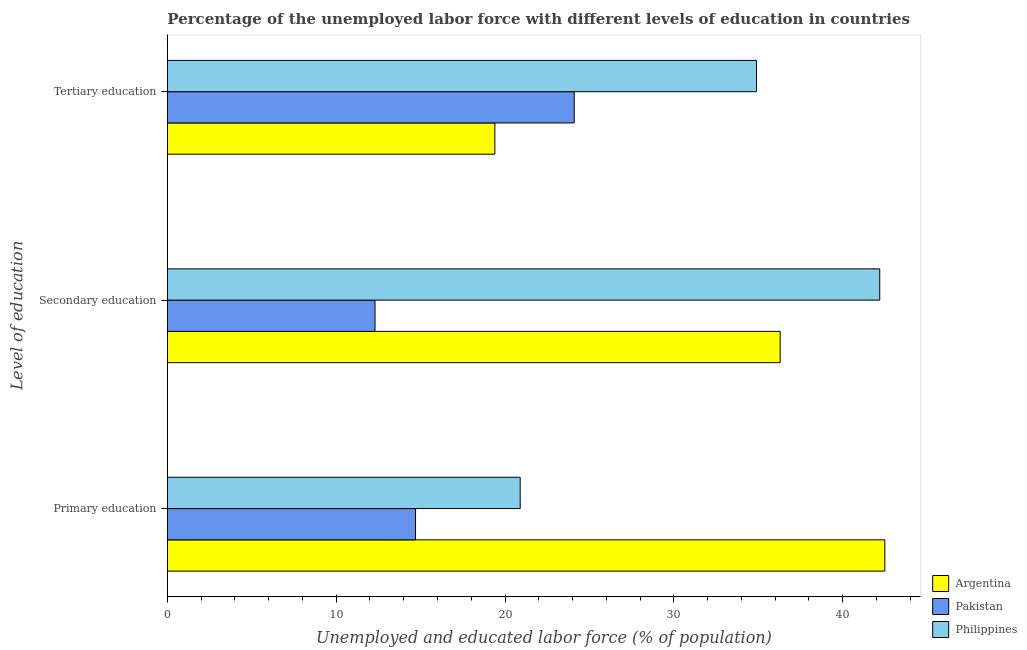Are the number of bars per tick equal to the number of legend labels?
Make the answer very short. Yes. How many bars are there on the 3rd tick from the top?
Offer a very short reply. 3. What is the label of the 3rd group of bars from the top?
Your answer should be compact. Primary education. What is the percentage of labor force who received secondary education in Argentina?
Give a very brief answer. 36.3. Across all countries, what is the maximum percentage of labor force who received primary education?
Offer a terse response. 42.5. Across all countries, what is the minimum percentage of labor force who received secondary education?
Offer a very short reply. 12.3. In which country was the percentage of labor force who received tertiary education maximum?
Provide a succinct answer. Philippines. What is the total percentage of labor force who received secondary education in the graph?
Make the answer very short. 90.8. What is the difference between the percentage of labor force who received secondary education in Philippines and that in Pakistan?
Your response must be concise. 29.9. What is the difference between the percentage of labor force who received primary education in Argentina and the percentage of labor force who received tertiary education in Pakistan?
Make the answer very short. 18.4. What is the average percentage of labor force who received tertiary education per country?
Your answer should be very brief. 26.13. What is the difference between the percentage of labor force who received tertiary education and percentage of labor force who received secondary education in Pakistan?
Your answer should be very brief. 11.8. In how many countries, is the percentage of labor force who received secondary education greater than 14 %?
Offer a very short reply. 2. What is the ratio of the percentage of labor force who received tertiary education in Philippines to that in Argentina?
Ensure brevity in your answer.  1.8. What is the difference between the highest and the second highest percentage of labor force who received secondary education?
Provide a succinct answer. 5.9. What is the difference between the highest and the lowest percentage of labor force who received primary education?
Your response must be concise. 27.8. Is the sum of the percentage of labor force who received tertiary education in Argentina and Philippines greater than the maximum percentage of labor force who received secondary education across all countries?
Keep it short and to the point. Yes. How many bars are there?
Provide a succinct answer. 9. Are all the bars in the graph horizontal?
Offer a terse response. Yes. How many countries are there in the graph?
Ensure brevity in your answer.  3. What is the difference between two consecutive major ticks on the X-axis?
Keep it short and to the point. 10. Does the graph contain any zero values?
Provide a short and direct response. No. Where does the legend appear in the graph?
Your answer should be very brief. Bottom right. How many legend labels are there?
Your answer should be compact. 3. How are the legend labels stacked?
Provide a succinct answer. Vertical. What is the title of the graph?
Keep it short and to the point. Percentage of the unemployed labor force with different levels of education in countries. What is the label or title of the X-axis?
Ensure brevity in your answer.  Unemployed and educated labor force (% of population). What is the label or title of the Y-axis?
Ensure brevity in your answer.  Level of education. What is the Unemployed and educated labor force (% of population) in Argentina in Primary education?
Provide a succinct answer. 42.5. What is the Unemployed and educated labor force (% of population) in Pakistan in Primary education?
Ensure brevity in your answer.  14.7. What is the Unemployed and educated labor force (% of population) of Philippines in Primary education?
Make the answer very short. 20.9. What is the Unemployed and educated labor force (% of population) in Argentina in Secondary education?
Offer a very short reply. 36.3. What is the Unemployed and educated labor force (% of population) in Pakistan in Secondary education?
Your response must be concise. 12.3. What is the Unemployed and educated labor force (% of population) of Philippines in Secondary education?
Ensure brevity in your answer.  42.2. What is the Unemployed and educated labor force (% of population) of Argentina in Tertiary education?
Offer a very short reply. 19.4. What is the Unemployed and educated labor force (% of population) of Pakistan in Tertiary education?
Keep it short and to the point. 24.1. What is the Unemployed and educated labor force (% of population) in Philippines in Tertiary education?
Your answer should be compact. 34.9. Across all Level of education, what is the maximum Unemployed and educated labor force (% of population) in Argentina?
Offer a terse response. 42.5. Across all Level of education, what is the maximum Unemployed and educated labor force (% of population) in Pakistan?
Give a very brief answer. 24.1. Across all Level of education, what is the maximum Unemployed and educated labor force (% of population) in Philippines?
Your answer should be compact. 42.2. Across all Level of education, what is the minimum Unemployed and educated labor force (% of population) in Argentina?
Offer a terse response. 19.4. Across all Level of education, what is the minimum Unemployed and educated labor force (% of population) in Pakistan?
Make the answer very short. 12.3. Across all Level of education, what is the minimum Unemployed and educated labor force (% of population) of Philippines?
Your answer should be compact. 20.9. What is the total Unemployed and educated labor force (% of population) in Argentina in the graph?
Offer a very short reply. 98.2. What is the total Unemployed and educated labor force (% of population) in Pakistan in the graph?
Your answer should be very brief. 51.1. What is the difference between the Unemployed and educated labor force (% of population) in Pakistan in Primary education and that in Secondary education?
Keep it short and to the point. 2.4. What is the difference between the Unemployed and educated labor force (% of population) of Philippines in Primary education and that in Secondary education?
Offer a terse response. -21.3. What is the difference between the Unemployed and educated labor force (% of population) of Argentina in Primary education and that in Tertiary education?
Provide a short and direct response. 23.1. What is the difference between the Unemployed and educated labor force (% of population) in Argentina in Secondary education and that in Tertiary education?
Offer a very short reply. 16.9. What is the difference between the Unemployed and educated labor force (% of population) of Philippines in Secondary education and that in Tertiary education?
Ensure brevity in your answer.  7.3. What is the difference between the Unemployed and educated labor force (% of population) in Argentina in Primary education and the Unemployed and educated labor force (% of population) in Pakistan in Secondary education?
Offer a terse response. 30.2. What is the difference between the Unemployed and educated labor force (% of population) of Argentina in Primary education and the Unemployed and educated labor force (% of population) of Philippines in Secondary education?
Make the answer very short. 0.3. What is the difference between the Unemployed and educated labor force (% of population) of Pakistan in Primary education and the Unemployed and educated labor force (% of population) of Philippines in Secondary education?
Keep it short and to the point. -27.5. What is the difference between the Unemployed and educated labor force (% of population) of Argentina in Primary education and the Unemployed and educated labor force (% of population) of Pakistan in Tertiary education?
Ensure brevity in your answer.  18.4. What is the difference between the Unemployed and educated labor force (% of population) of Argentina in Primary education and the Unemployed and educated labor force (% of population) of Philippines in Tertiary education?
Provide a succinct answer. 7.6. What is the difference between the Unemployed and educated labor force (% of population) of Pakistan in Primary education and the Unemployed and educated labor force (% of population) of Philippines in Tertiary education?
Provide a short and direct response. -20.2. What is the difference between the Unemployed and educated labor force (% of population) in Argentina in Secondary education and the Unemployed and educated labor force (% of population) in Pakistan in Tertiary education?
Give a very brief answer. 12.2. What is the difference between the Unemployed and educated labor force (% of population) of Argentina in Secondary education and the Unemployed and educated labor force (% of population) of Philippines in Tertiary education?
Keep it short and to the point. 1.4. What is the difference between the Unemployed and educated labor force (% of population) of Pakistan in Secondary education and the Unemployed and educated labor force (% of population) of Philippines in Tertiary education?
Ensure brevity in your answer.  -22.6. What is the average Unemployed and educated labor force (% of population) of Argentina per Level of education?
Give a very brief answer. 32.73. What is the average Unemployed and educated labor force (% of population) of Pakistan per Level of education?
Offer a very short reply. 17.03. What is the average Unemployed and educated labor force (% of population) of Philippines per Level of education?
Give a very brief answer. 32.67. What is the difference between the Unemployed and educated labor force (% of population) of Argentina and Unemployed and educated labor force (% of population) of Pakistan in Primary education?
Ensure brevity in your answer.  27.8. What is the difference between the Unemployed and educated labor force (% of population) of Argentina and Unemployed and educated labor force (% of population) of Philippines in Primary education?
Provide a succinct answer. 21.6. What is the difference between the Unemployed and educated labor force (% of population) in Argentina and Unemployed and educated labor force (% of population) in Pakistan in Secondary education?
Offer a terse response. 24. What is the difference between the Unemployed and educated labor force (% of population) of Pakistan and Unemployed and educated labor force (% of population) of Philippines in Secondary education?
Provide a short and direct response. -29.9. What is the difference between the Unemployed and educated labor force (% of population) in Argentina and Unemployed and educated labor force (% of population) in Pakistan in Tertiary education?
Your response must be concise. -4.7. What is the difference between the Unemployed and educated labor force (% of population) in Argentina and Unemployed and educated labor force (% of population) in Philippines in Tertiary education?
Give a very brief answer. -15.5. What is the difference between the Unemployed and educated labor force (% of population) in Pakistan and Unemployed and educated labor force (% of population) in Philippines in Tertiary education?
Make the answer very short. -10.8. What is the ratio of the Unemployed and educated labor force (% of population) in Argentina in Primary education to that in Secondary education?
Your answer should be very brief. 1.17. What is the ratio of the Unemployed and educated labor force (% of population) in Pakistan in Primary education to that in Secondary education?
Provide a succinct answer. 1.2. What is the ratio of the Unemployed and educated labor force (% of population) of Philippines in Primary education to that in Secondary education?
Keep it short and to the point. 0.5. What is the ratio of the Unemployed and educated labor force (% of population) in Argentina in Primary education to that in Tertiary education?
Provide a short and direct response. 2.19. What is the ratio of the Unemployed and educated labor force (% of population) of Pakistan in Primary education to that in Tertiary education?
Provide a short and direct response. 0.61. What is the ratio of the Unemployed and educated labor force (% of population) of Philippines in Primary education to that in Tertiary education?
Provide a short and direct response. 0.6. What is the ratio of the Unemployed and educated labor force (% of population) in Argentina in Secondary education to that in Tertiary education?
Offer a terse response. 1.87. What is the ratio of the Unemployed and educated labor force (% of population) of Pakistan in Secondary education to that in Tertiary education?
Make the answer very short. 0.51. What is the ratio of the Unemployed and educated labor force (% of population) in Philippines in Secondary education to that in Tertiary education?
Your response must be concise. 1.21. What is the difference between the highest and the second highest Unemployed and educated labor force (% of population) in Pakistan?
Your response must be concise. 9.4. What is the difference between the highest and the second highest Unemployed and educated labor force (% of population) of Philippines?
Your response must be concise. 7.3. What is the difference between the highest and the lowest Unemployed and educated labor force (% of population) in Argentina?
Ensure brevity in your answer.  23.1. What is the difference between the highest and the lowest Unemployed and educated labor force (% of population) of Philippines?
Your answer should be very brief. 21.3. 